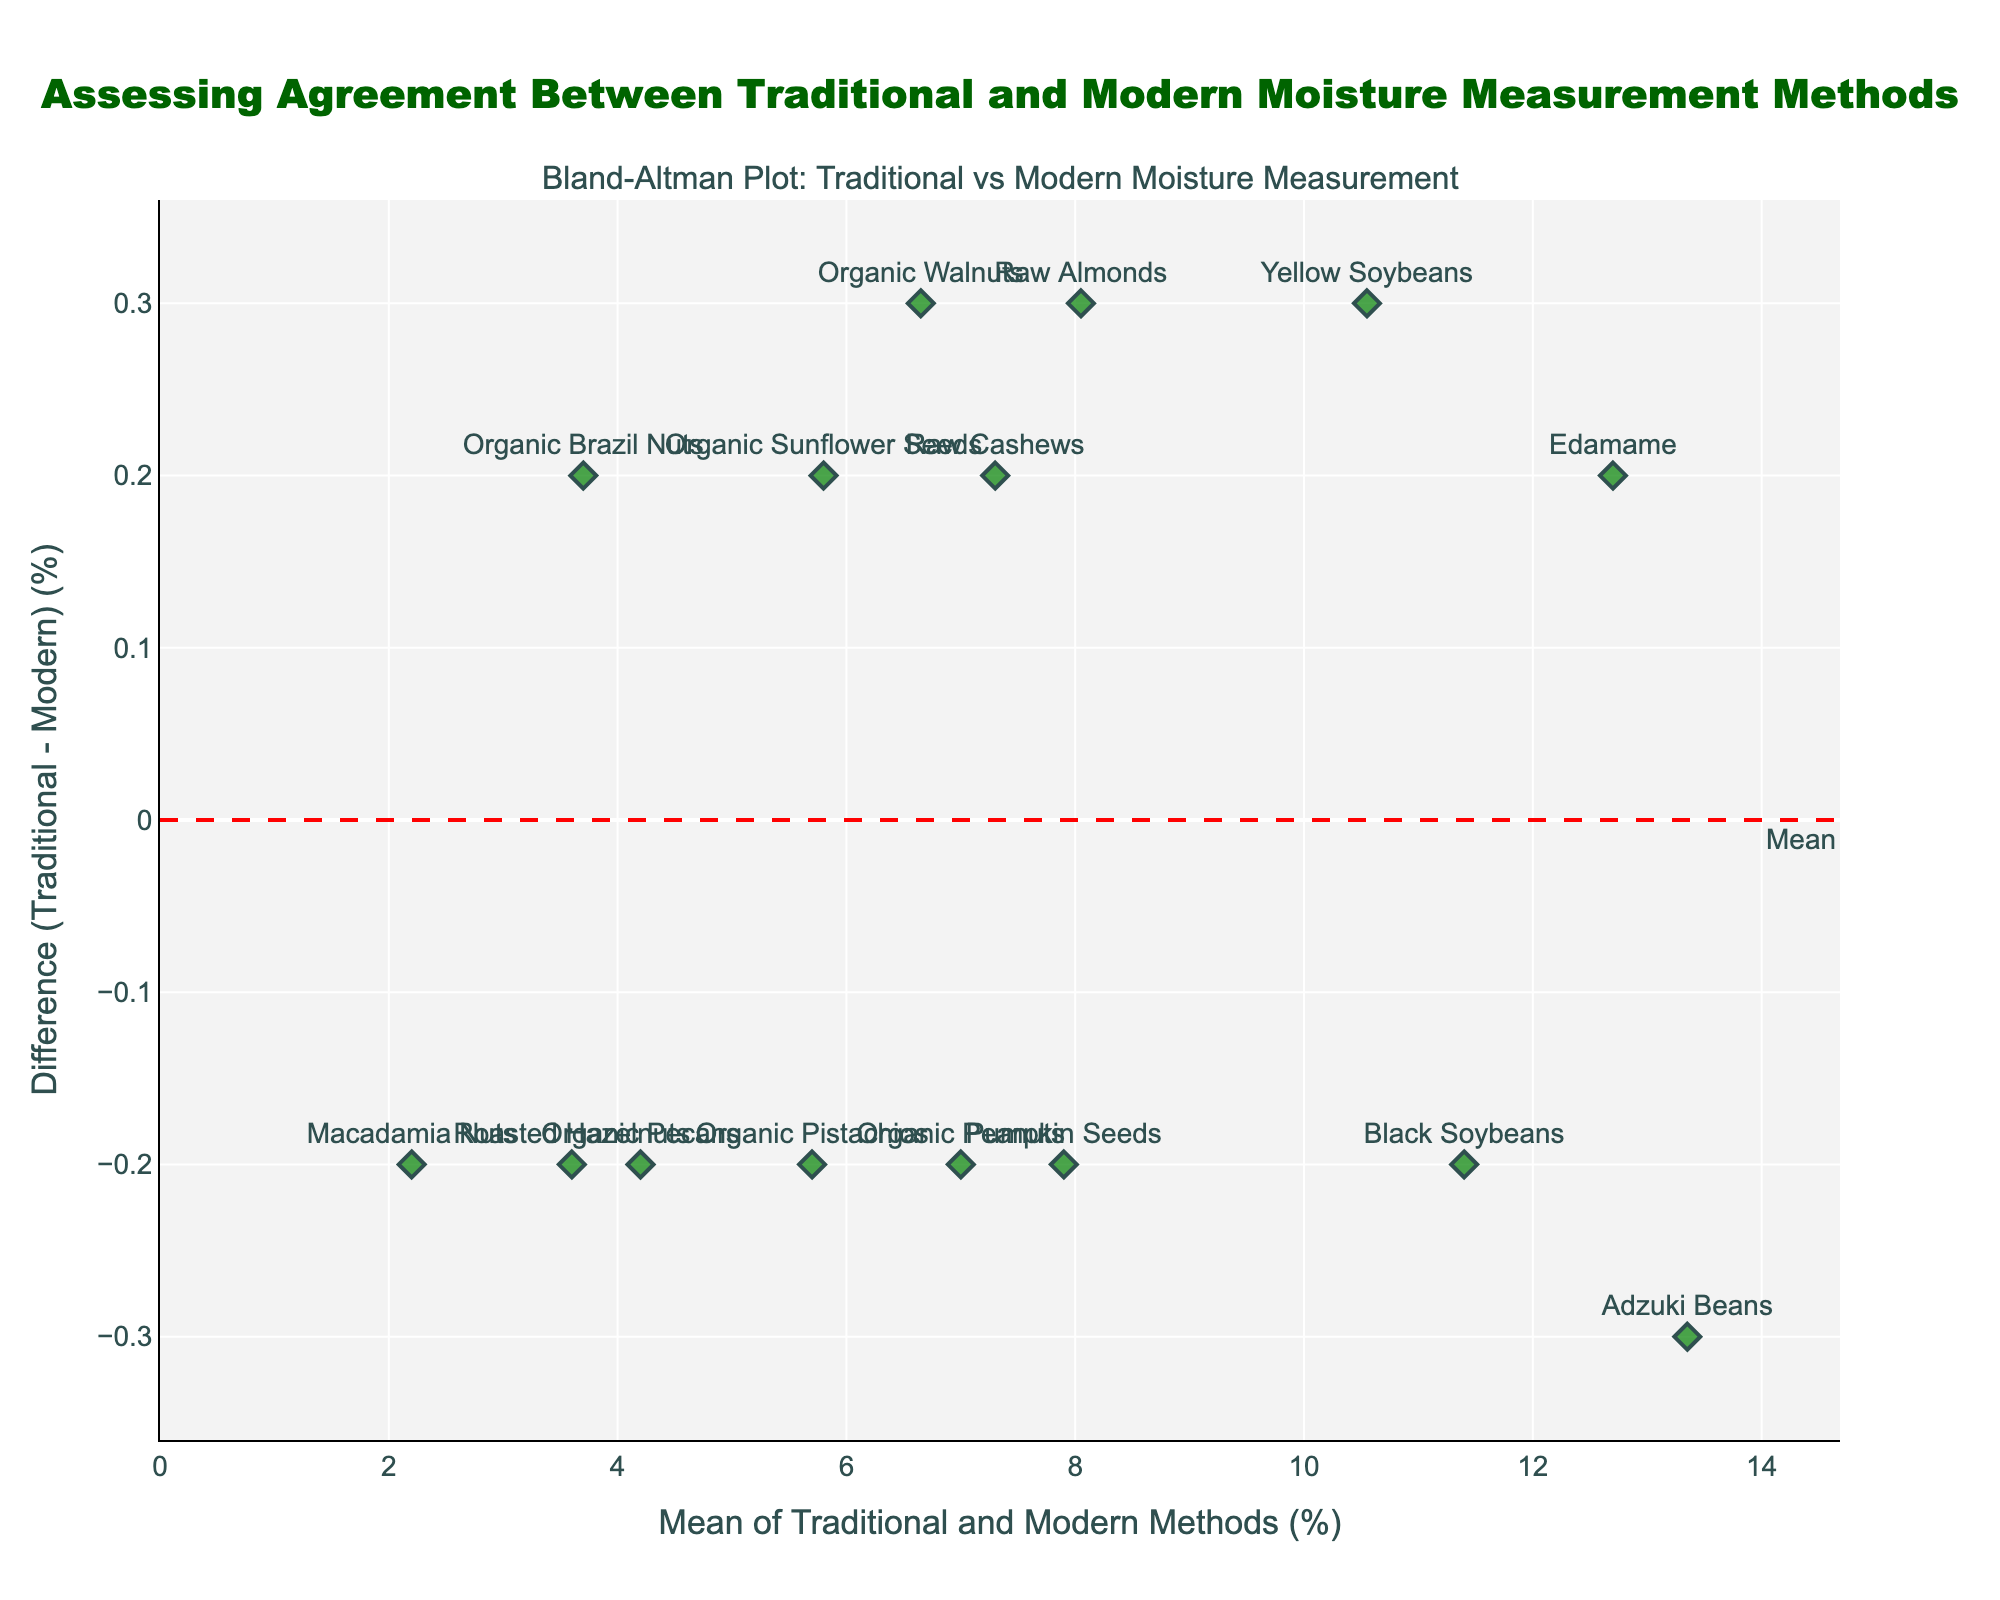What's the title of the figure? The title is usually displayed at the top of the figure. In this case, it is written in a readable format, emphasizing the main idea.
Answer: "Assessing Agreement Between Traditional and Modern Moisture Measurement Methods" How many data points are plotted on the Bland-Altman plot? Count the number of markers (diamonds) on the plot. Each marker represents one data point.
Answer: 15 What are the x-axis and y-axis labels? The x-axis label and y-axis label describe what the axes represent. They are usually mentioned on the plot.
Answer: "Mean of Traditional and Modern Methods (%)" and "Difference (Traditional - Modern) (%)" What is the general color and shape of the data points? Observe the markers' visual characteristics such as color and shape used in the plot.
Answer: Green diamonds What is the mean difference between the traditional and modern measurement methods? The mean difference is highlighted by a dashed red line with an annotation text "Mean". Look at the y-position of this line.
Answer: Around 0 Which two types of nuts show the greatest positive difference between the traditional and modern methods? Look for the highest points above the mean difference line in the plot. Identify the corresponding nuts using the marker labels.
Answer: Adzuki Beans and Black Soybeans What is the range of differences between the traditional and modern methods? Check the minimum and maximum values on the y-axis to determine the range.
Answer: Approximately -0.3 to 0.3 Which data point shows the smallest difference between the two measurement methods? Identify the data point closest to the 0 difference line.
Answer: Organic Walnuts What are the upper and lower limits of agreement? The upper and lower limits are indicated by the dotted orange lines labeled "+1.96 SD" and "-1.96 SD". Observe their y-positions.
Answer: Around 0.17 and -0.17 Are there any data points outside the limits of agreement? Check if there are any markers outside the dotted orange lines (limits of agreement).
Answer: No 